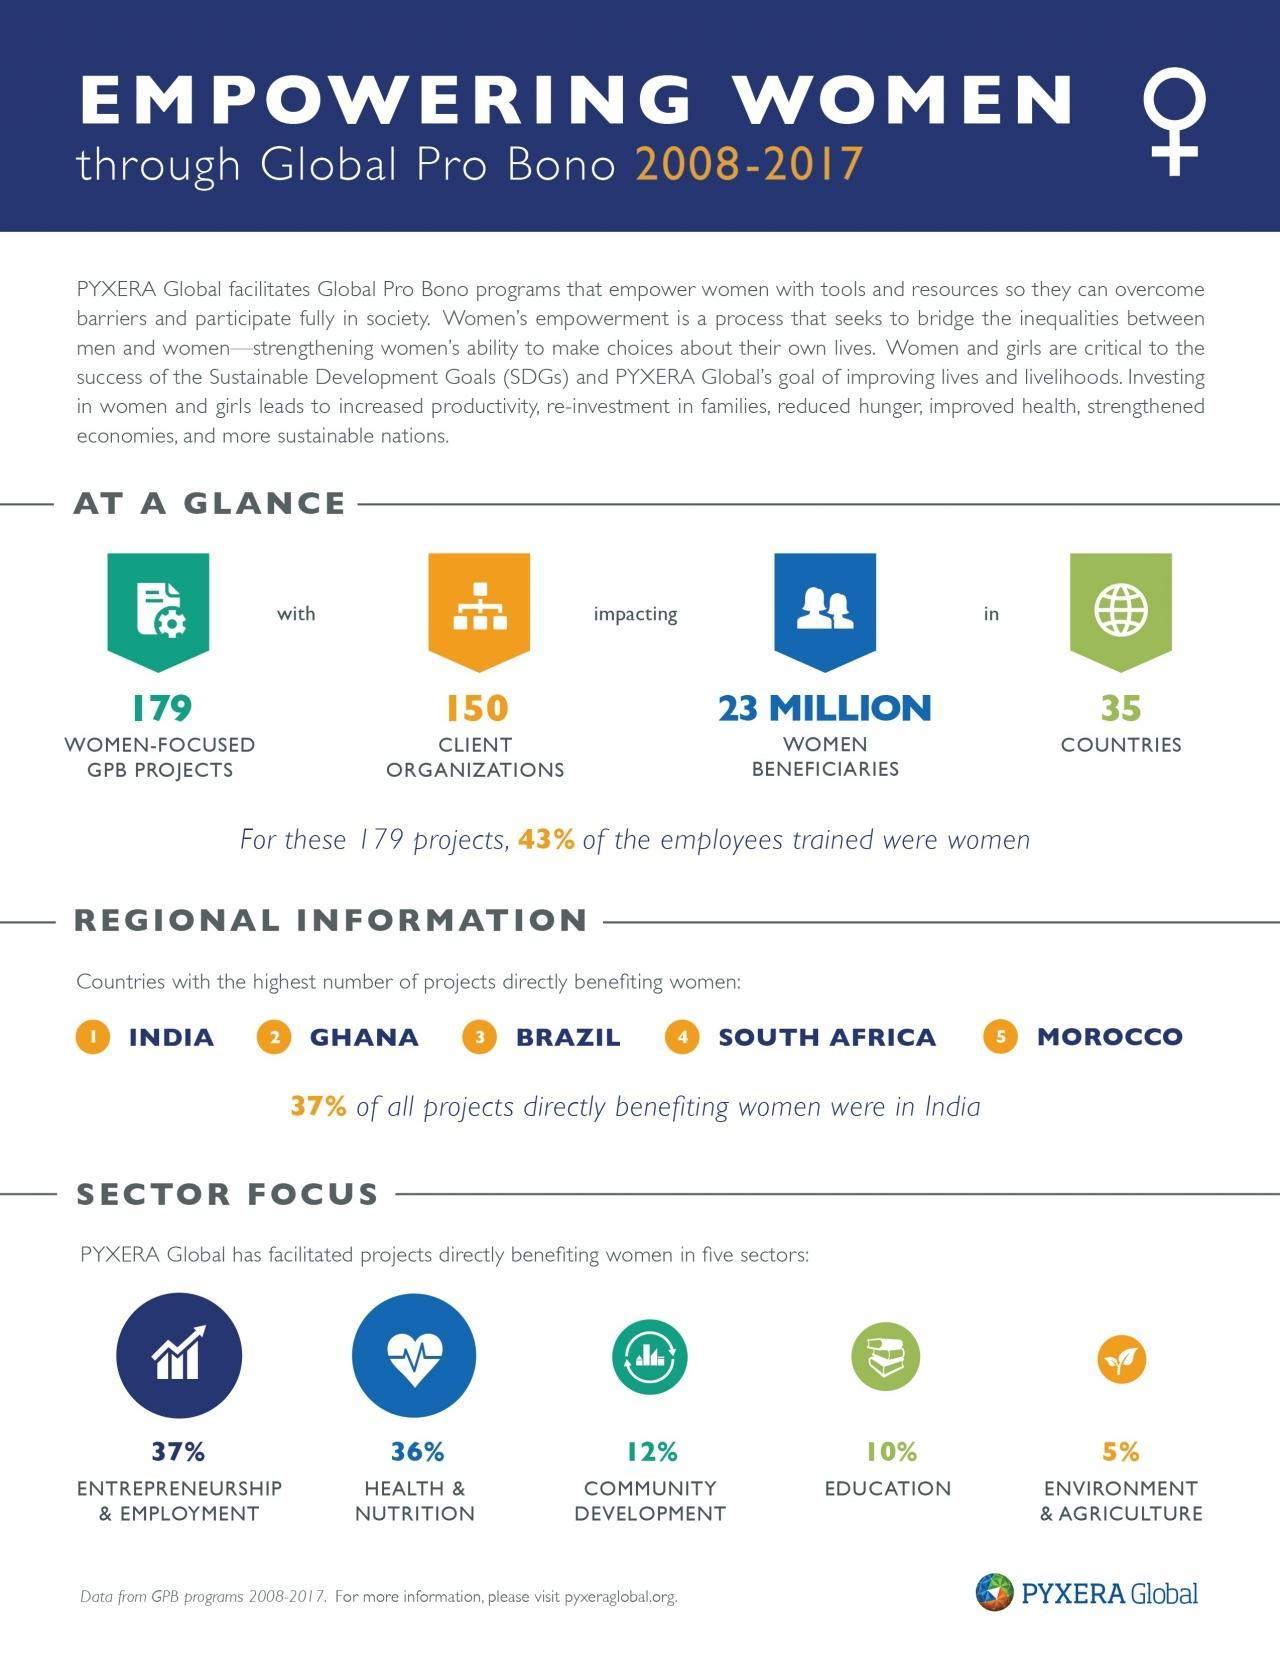Which country has the highest number of projects directly benefiting women after India from 2008 to 2017?
Answer the question with a short phrase. GHANA What percentage of projects facilitated by PYXERA Global is aimed at women's health & nutrition during 2008-2017? 36% What percentage of projects facilitated by PYXERA Global is aimed at women's education during 2008-2017? 10% How many countries were benefited from the women focussed GPB projects during 2008-2017? 35 